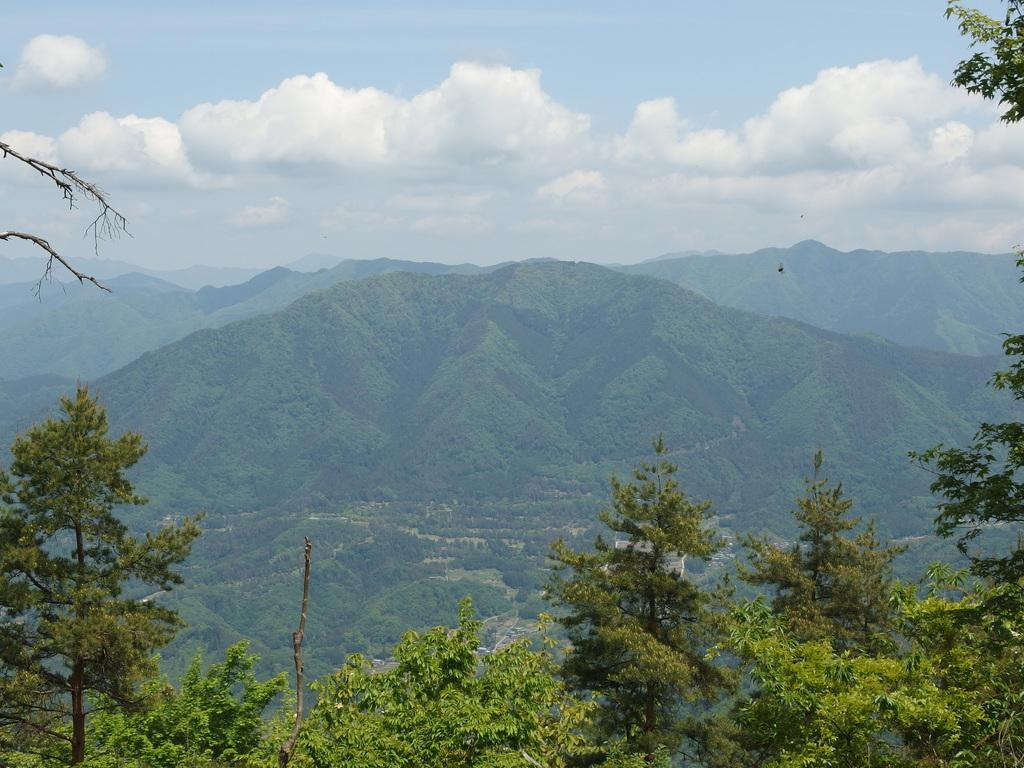What type of natural features can be seen in the image? There are trees and mountains in the image. What is visible in the background of the image? The sky is visible in the background of the image. What can be observed in the sky? Clouds are present in the sky. What type of peace is being negotiated by the judge in the image? There is no judge or negotiation present in the image; it features trees, mountains, and clouds in the sky. How does the digestion process of the trees in the image work? Trees do not have a digestion process; they absorb nutrients through their roots and produce energy through photosynthesis. 